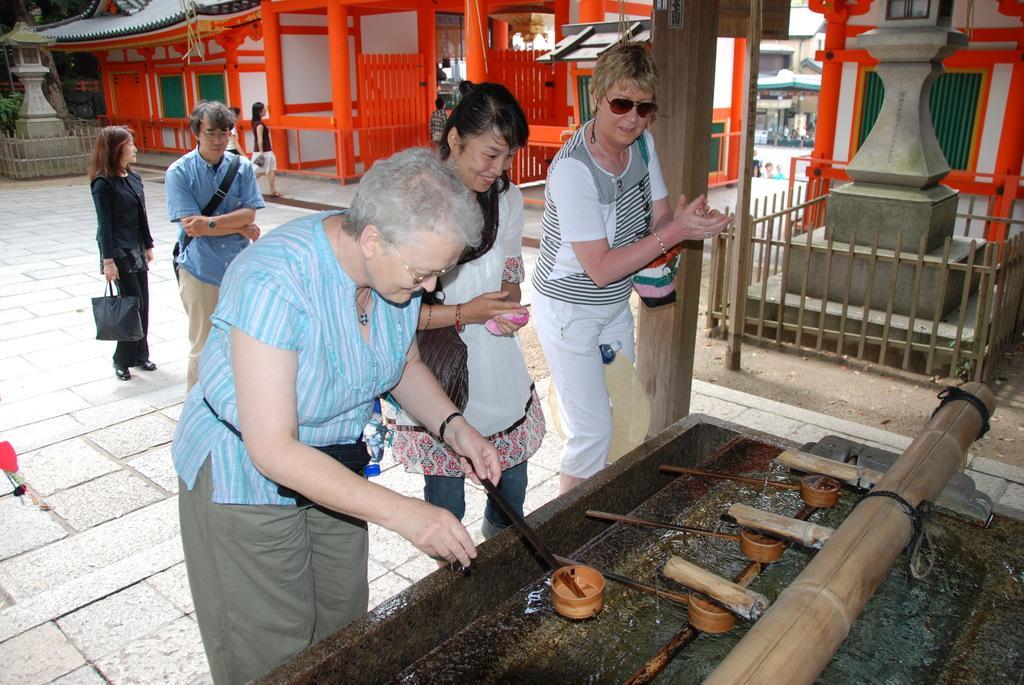Could you give a brief overview of what you see in this image? This image consists of few persons. In the front, the woman wearing a blue top is holding a stick. In the background, there are many pillars and gate. At the bottom, there is a floor. On the right, there is a fencing around a pillar. At the bottom, we can the water and a wooden stick. 